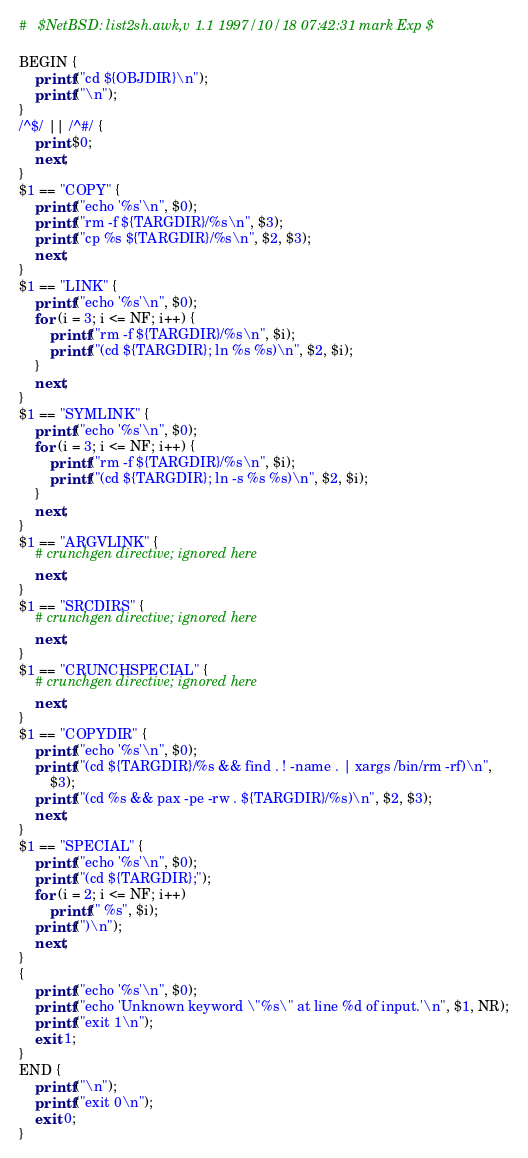Convert code to text. <code><loc_0><loc_0><loc_500><loc_500><_Awk_>#	$NetBSD: list2sh.awk,v 1.1 1997/10/18 07:42:31 mark Exp $

BEGIN {
	printf("cd ${OBJDIR}\n");
	printf("\n");
}
/^$/ || /^#/ {
	print $0;
	next;
}
$1 == "COPY" {
	printf("echo '%s'\n", $0);
	printf("rm -f ${TARGDIR}/%s\n", $3);
	printf("cp %s ${TARGDIR}/%s\n", $2, $3);
	next;
}
$1 == "LINK" {
	printf("echo '%s'\n", $0);
	for (i = 3; i <= NF; i++) {
		printf("rm -f ${TARGDIR}/%s\n", $i);
		printf("(cd ${TARGDIR}; ln %s %s)\n", $2, $i);
	}
	next;
}
$1 == "SYMLINK" {
	printf("echo '%s'\n", $0);
	for (i = 3; i <= NF; i++) {
		printf("rm -f ${TARGDIR}/%s\n", $i);
		printf("(cd ${TARGDIR}; ln -s %s %s)\n", $2, $i);
	}
	next;
}
$1 == "ARGVLINK" {
	# crunchgen directive; ignored here
	next;
}
$1 == "SRCDIRS" {
	# crunchgen directive; ignored here
	next;
}
$1 == "CRUNCHSPECIAL" {
	# crunchgen directive; ignored here
	next;
}
$1 == "COPYDIR" {
	printf("echo '%s'\n", $0);
	printf("(cd ${TARGDIR}/%s && find . ! -name . | xargs /bin/rm -rf)\n",
	    $3);
	printf("(cd %s && pax -pe -rw . ${TARGDIR}/%s)\n", $2, $3);
	next;
}
$1 == "SPECIAL" {
	printf("echo '%s'\n", $0);
	printf("(cd ${TARGDIR};");
	for (i = 2; i <= NF; i++)
		printf(" %s", $i);
	printf(")\n");
	next;
}
{
	printf("echo '%s'\n", $0);
	printf("echo 'Unknown keyword \"%s\" at line %d of input.'\n", $1, NR);
	printf("exit 1\n");
	exit 1;
}
END {
	printf("\n");
	printf("exit 0\n");
	exit 0;
}
</code> 